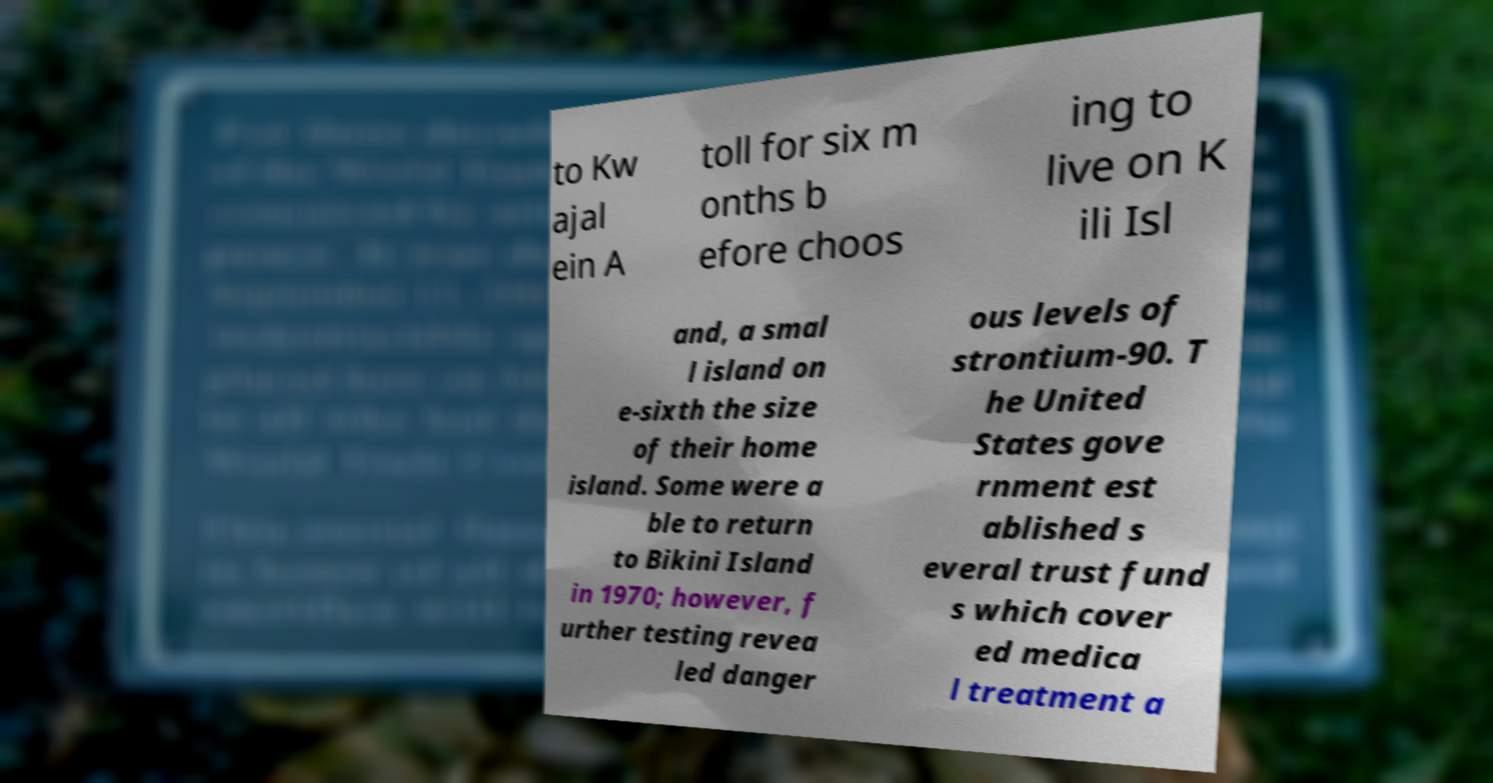For documentation purposes, I need the text within this image transcribed. Could you provide that? to Kw ajal ein A toll for six m onths b efore choos ing to live on K ili Isl and, a smal l island on e-sixth the size of their home island. Some were a ble to return to Bikini Island in 1970; however, f urther testing revea led danger ous levels of strontium-90. T he United States gove rnment est ablished s everal trust fund s which cover ed medica l treatment a 